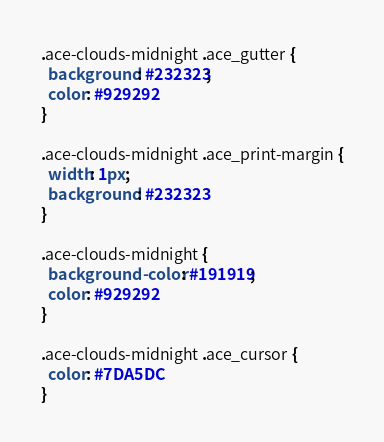<code> <loc_0><loc_0><loc_500><loc_500><_CSS_>.ace-clouds-midnight .ace_gutter {
  background: #232323;
  color: #929292
}

.ace-clouds-midnight .ace_print-margin {
  width: 1px;
  background: #232323
}

.ace-clouds-midnight {
  background-color: #191919;
  color: #929292
}

.ace-clouds-midnight .ace_cursor {
  color: #7DA5DC
}
</code> 